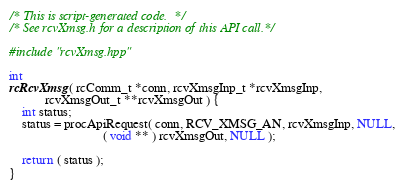<code> <loc_0><loc_0><loc_500><loc_500><_C++_>/* This is script-generated code.  */
/* See rcvXmsg.h for a description of this API call.*/

#include "rcvXmsg.hpp"

int
rcRcvXmsg( rcComm_t *conn, rcvXmsgInp_t *rcvXmsgInp,
           rcvXmsgOut_t **rcvXmsgOut ) {
    int status;
    status = procApiRequest( conn, RCV_XMSG_AN, rcvXmsgInp, NULL,
                             ( void ** ) rcvXmsgOut, NULL );

    return ( status );
}
</code> 